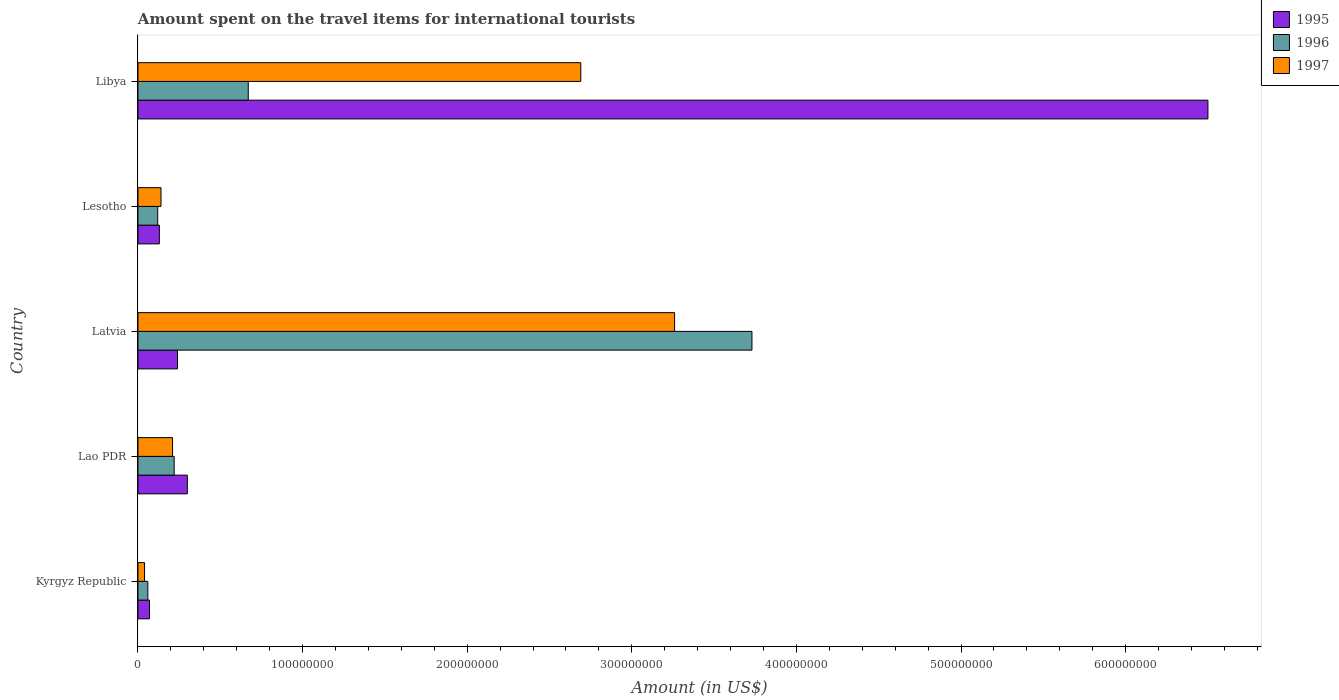How many bars are there on the 1st tick from the top?
Ensure brevity in your answer.  3. What is the label of the 2nd group of bars from the top?
Keep it short and to the point. Lesotho. What is the amount spent on the travel items for international tourists in 1995 in Lesotho?
Ensure brevity in your answer.  1.30e+07. Across all countries, what is the maximum amount spent on the travel items for international tourists in 1995?
Your answer should be very brief. 6.50e+08. Across all countries, what is the minimum amount spent on the travel items for international tourists in 1995?
Your answer should be compact. 7.00e+06. In which country was the amount spent on the travel items for international tourists in 1997 maximum?
Offer a very short reply. Latvia. In which country was the amount spent on the travel items for international tourists in 1996 minimum?
Provide a short and direct response. Kyrgyz Republic. What is the total amount spent on the travel items for international tourists in 1995 in the graph?
Offer a terse response. 7.24e+08. What is the difference between the amount spent on the travel items for international tourists in 1995 in Latvia and that in Lesotho?
Offer a terse response. 1.10e+07. What is the difference between the amount spent on the travel items for international tourists in 1995 in Lesotho and the amount spent on the travel items for international tourists in 1997 in Libya?
Ensure brevity in your answer.  -2.56e+08. What is the average amount spent on the travel items for international tourists in 1997 per country?
Provide a succinct answer. 1.27e+08. What is the difference between the amount spent on the travel items for international tourists in 1996 and amount spent on the travel items for international tourists in 1995 in Kyrgyz Republic?
Your answer should be compact. -1.00e+06. In how many countries, is the amount spent on the travel items for international tourists in 1995 greater than 420000000 US$?
Offer a terse response. 1. What is the ratio of the amount spent on the travel items for international tourists in 1997 in Lao PDR to that in Libya?
Offer a terse response. 0.08. Is the amount spent on the travel items for international tourists in 1997 in Kyrgyz Republic less than that in Libya?
Make the answer very short. Yes. What is the difference between the highest and the second highest amount spent on the travel items for international tourists in 1995?
Provide a succinct answer. 6.20e+08. What is the difference between the highest and the lowest amount spent on the travel items for international tourists in 1995?
Make the answer very short. 6.43e+08. Is the sum of the amount spent on the travel items for international tourists in 1995 in Lao PDR and Lesotho greater than the maximum amount spent on the travel items for international tourists in 1997 across all countries?
Your response must be concise. No. What does the 3rd bar from the bottom in Latvia represents?
Your answer should be compact. 1997. How many bars are there?
Your response must be concise. 15. How many countries are there in the graph?
Make the answer very short. 5. Are the values on the major ticks of X-axis written in scientific E-notation?
Your response must be concise. No. Does the graph contain any zero values?
Make the answer very short. No. How many legend labels are there?
Provide a short and direct response. 3. What is the title of the graph?
Offer a very short reply. Amount spent on the travel items for international tourists. Does "1962" appear as one of the legend labels in the graph?
Keep it short and to the point. No. What is the label or title of the Y-axis?
Your answer should be compact. Country. What is the Amount (in US$) in 1995 in Kyrgyz Republic?
Provide a succinct answer. 7.00e+06. What is the Amount (in US$) in 1997 in Kyrgyz Republic?
Your answer should be very brief. 4.00e+06. What is the Amount (in US$) of 1995 in Lao PDR?
Your answer should be compact. 3.00e+07. What is the Amount (in US$) in 1996 in Lao PDR?
Your answer should be compact. 2.20e+07. What is the Amount (in US$) of 1997 in Lao PDR?
Give a very brief answer. 2.10e+07. What is the Amount (in US$) of 1995 in Latvia?
Offer a very short reply. 2.40e+07. What is the Amount (in US$) of 1996 in Latvia?
Your response must be concise. 3.73e+08. What is the Amount (in US$) of 1997 in Latvia?
Offer a terse response. 3.26e+08. What is the Amount (in US$) in 1995 in Lesotho?
Make the answer very short. 1.30e+07. What is the Amount (in US$) of 1996 in Lesotho?
Offer a very short reply. 1.20e+07. What is the Amount (in US$) of 1997 in Lesotho?
Offer a terse response. 1.40e+07. What is the Amount (in US$) in 1995 in Libya?
Provide a succinct answer. 6.50e+08. What is the Amount (in US$) of 1996 in Libya?
Offer a very short reply. 6.70e+07. What is the Amount (in US$) in 1997 in Libya?
Make the answer very short. 2.69e+08. Across all countries, what is the maximum Amount (in US$) in 1995?
Make the answer very short. 6.50e+08. Across all countries, what is the maximum Amount (in US$) of 1996?
Your response must be concise. 3.73e+08. Across all countries, what is the maximum Amount (in US$) in 1997?
Offer a very short reply. 3.26e+08. Across all countries, what is the minimum Amount (in US$) of 1995?
Ensure brevity in your answer.  7.00e+06. What is the total Amount (in US$) in 1995 in the graph?
Your answer should be very brief. 7.24e+08. What is the total Amount (in US$) of 1996 in the graph?
Provide a succinct answer. 4.80e+08. What is the total Amount (in US$) in 1997 in the graph?
Ensure brevity in your answer.  6.34e+08. What is the difference between the Amount (in US$) of 1995 in Kyrgyz Republic and that in Lao PDR?
Keep it short and to the point. -2.30e+07. What is the difference between the Amount (in US$) of 1996 in Kyrgyz Republic and that in Lao PDR?
Make the answer very short. -1.60e+07. What is the difference between the Amount (in US$) in 1997 in Kyrgyz Republic and that in Lao PDR?
Your answer should be very brief. -1.70e+07. What is the difference between the Amount (in US$) of 1995 in Kyrgyz Republic and that in Latvia?
Provide a succinct answer. -1.70e+07. What is the difference between the Amount (in US$) in 1996 in Kyrgyz Republic and that in Latvia?
Give a very brief answer. -3.67e+08. What is the difference between the Amount (in US$) of 1997 in Kyrgyz Republic and that in Latvia?
Your response must be concise. -3.22e+08. What is the difference between the Amount (in US$) in 1995 in Kyrgyz Republic and that in Lesotho?
Offer a very short reply. -6.00e+06. What is the difference between the Amount (in US$) in 1996 in Kyrgyz Republic and that in Lesotho?
Your answer should be compact. -6.00e+06. What is the difference between the Amount (in US$) of 1997 in Kyrgyz Republic and that in Lesotho?
Keep it short and to the point. -1.00e+07. What is the difference between the Amount (in US$) in 1995 in Kyrgyz Republic and that in Libya?
Provide a short and direct response. -6.43e+08. What is the difference between the Amount (in US$) of 1996 in Kyrgyz Republic and that in Libya?
Your answer should be compact. -6.10e+07. What is the difference between the Amount (in US$) in 1997 in Kyrgyz Republic and that in Libya?
Make the answer very short. -2.65e+08. What is the difference between the Amount (in US$) in 1995 in Lao PDR and that in Latvia?
Keep it short and to the point. 6.00e+06. What is the difference between the Amount (in US$) in 1996 in Lao PDR and that in Latvia?
Provide a succinct answer. -3.51e+08. What is the difference between the Amount (in US$) of 1997 in Lao PDR and that in Latvia?
Provide a succinct answer. -3.05e+08. What is the difference between the Amount (in US$) of 1995 in Lao PDR and that in Lesotho?
Your answer should be very brief. 1.70e+07. What is the difference between the Amount (in US$) of 1997 in Lao PDR and that in Lesotho?
Offer a very short reply. 7.00e+06. What is the difference between the Amount (in US$) of 1995 in Lao PDR and that in Libya?
Keep it short and to the point. -6.20e+08. What is the difference between the Amount (in US$) of 1996 in Lao PDR and that in Libya?
Your answer should be very brief. -4.50e+07. What is the difference between the Amount (in US$) in 1997 in Lao PDR and that in Libya?
Your answer should be compact. -2.48e+08. What is the difference between the Amount (in US$) in 1995 in Latvia and that in Lesotho?
Make the answer very short. 1.10e+07. What is the difference between the Amount (in US$) of 1996 in Latvia and that in Lesotho?
Provide a succinct answer. 3.61e+08. What is the difference between the Amount (in US$) in 1997 in Latvia and that in Lesotho?
Provide a short and direct response. 3.12e+08. What is the difference between the Amount (in US$) of 1995 in Latvia and that in Libya?
Keep it short and to the point. -6.26e+08. What is the difference between the Amount (in US$) of 1996 in Latvia and that in Libya?
Your answer should be compact. 3.06e+08. What is the difference between the Amount (in US$) in 1997 in Latvia and that in Libya?
Provide a short and direct response. 5.70e+07. What is the difference between the Amount (in US$) in 1995 in Lesotho and that in Libya?
Your answer should be compact. -6.37e+08. What is the difference between the Amount (in US$) of 1996 in Lesotho and that in Libya?
Offer a very short reply. -5.50e+07. What is the difference between the Amount (in US$) in 1997 in Lesotho and that in Libya?
Ensure brevity in your answer.  -2.55e+08. What is the difference between the Amount (in US$) of 1995 in Kyrgyz Republic and the Amount (in US$) of 1996 in Lao PDR?
Your answer should be very brief. -1.50e+07. What is the difference between the Amount (in US$) of 1995 in Kyrgyz Republic and the Amount (in US$) of 1997 in Lao PDR?
Make the answer very short. -1.40e+07. What is the difference between the Amount (in US$) of 1996 in Kyrgyz Republic and the Amount (in US$) of 1997 in Lao PDR?
Your response must be concise. -1.50e+07. What is the difference between the Amount (in US$) of 1995 in Kyrgyz Republic and the Amount (in US$) of 1996 in Latvia?
Keep it short and to the point. -3.66e+08. What is the difference between the Amount (in US$) of 1995 in Kyrgyz Republic and the Amount (in US$) of 1997 in Latvia?
Make the answer very short. -3.19e+08. What is the difference between the Amount (in US$) of 1996 in Kyrgyz Republic and the Amount (in US$) of 1997 in Latvia?
Keep it short and to the point. -3.20e+08. What is the difference between the Amount (in US$) of 1995 in Kyrgyz Republic and the Amount (in US$) of 1996 in Lesotho?
Your answer should be very brief. -5.00e+06. What is the difference between the Amount (in US$) in 1995 in Kyrgyz Republic and the Amount (in US$) in 1997 in Lesotho?
Your response must be concise. -7.00e+06. What is the difference between the Amount (in US$) of 1996 in Kyrgyz Republic and the Amount (in US$) of 1997 in Lesotho?
Provide a short and direct response. -8.00e+06. What is the difference between the Amount (in US$) in 1995 in Kyrgyz Republic and the Amount (in US$) in 1996 in Libya?
Give a very brief answer. -6.00e+07. What is the difference between the Amount (in US$) of 1995 in Kyrgyz Republic and the Amount (in US$) of 1997 in Libya?
Your response must be concise. -2.62e+08. What is the difference between the Amount (in US$) in 1996 in Kyrgyz Republic and the Amount (in US$) in 1997 in Libya?
Your response must be concise. -2.63e+08. What is the difference between the Amount (in US$) of 1995 in Lao PDR and the Amount (in US$) of 1996 in Latvia?
Offer a terse response. -3.43e+08. What is the difference between the Amount (in US$) in 1995 in Lao PDR and the Amount (in US$) in 1997 in Latvia?
Offer a terse response. -2.96e+08. What is the difference between the Amount (in US$) of 1996 in Lao PDR and the Amount (in US$) of 1997 in Latvia?
Provide a succinct answer. -3.04e+08. What is the difference between the Amount (in US$) of 1995 in Lao PDR and the Amount (in US$) of 1996 in Lesotho?
Offer a terse response. 1.80e+07. What is the difference between the Amount (in US$) of 1995 in Lao PDR and the Amount (in US$) of 1997 in Lesotho?
Offer a very short reply. 1.60e+07. What is the difference between the Amount (in US$) in 1996 in Lao PDR and the Amount (in US$) in 1997 in Lesotho?
Ensure brevity in your answer.  8.00e+06. What is the difference between the Amount (in US$) in 1995 in Lao PDR and the Amount (in US$) in 1996 in Libya?
Your response must be concise. -3.70e+07. What is the difference between the Amount (in US$) of 1995 in Lao PDR and the Amount (in US$) of 1997 in Libya?
Offer a very short reply. -2.39e+08. What is the difference between the Amount (in US$) in 1996 in Lao PDR and the Amount (in US$) in 1997 in Libya?
Ensure brevity in your answer.  -2.47e+08. What is the difference between the Amount (in US$) in 1996 in Latvia and the Amount (in US$) in 1997 in Lesotho?
Offer a very short reply. 3.59e+08. What is the difference between the Amount (in US$) of 1995 in Latvia and the Amount (in US$) of 1996 in Libya?
Provide a short and direct response. -4.30e+07. What is the difference between the Amount (in US$) of 1995 in Latvia and the Amount (in US$) of 1997 in Libya?
Provide a short and direct response. -2.45e+08. What is the difference between the Amount (in US$) of 1996 in Latvia and the Amount (in US$) of 1997 in Libya?
Ensure brevity in your answer.  1.04e+08. What is the difference between the Amount (in US$) in 1995 in Lesotho and the Amount (in US$) in 1996 in Libya?
Your answer should be compact. -5.40e+07. What is the difference between the Amount (in US$) of 1995 in Lesotho and the Amount (in US$) of 1997 in Libya?
Make the answer very short. -2.56e+08. What is the difference between the Amount (in US$) of 1996 in Lesotho and the Amount (in US$) of 1997 in Libya?
Your answer should be compact. -2.57e+08. What is the average Amount (in US$) of 1995 per country?
Provide a short and direct response. 1.45e+08. What is the average Amount (in US$) in 1996 per country?
Ensure brevity in your answer.  9.60e+07. What is the average Amount (in US$) in 1997 per country?
Make the answer very short. 1.27e+08. What is the difference between the Amount (in US$) in 1995 and Amount (in US$) in 1996 in Kyrgyz Republic?
Offer a terse response. 1.00e+06. What is the difference between the Amount (in US$) in 1995 and Amount (in US$) in 1997 in Kyrgyz Republic?
Provide a succinct answer. 3.00e+06. What is the difference between the Amount (in US$) in 1995 and Amount (in US$) in 1996 in Lao PDR?
Give a very brief answer. 8.00e+06. What is the difference between the Amount (in US$) of 1995 and Amount (in US$) of 1997 in Lao PDR?
Offer a terse response. 9.00e+06. What is the difference between the Amount (in US$) in 1995 and Amount (in US$) in 1996 in Latvia?
Give a very brief answer. -3.49e+08. What is the difference between the Amount (in US$) in 1995 and Amount (in US$) in 1997 in Latvia?
Keep it short and to the point. -3.02e+08. What is the difference between the Amount (in US$) of 1996 and Amount (in US$) of 1997 in Latvia?
Provide a succinct answer. 4.70e+07. What is the difference between the Amount (in US$) of 1995 and Amount (in US$) of 1996 in Lesotho?
Provide a succinct answer. 1.00e+06. What is the difference between the Amount (in US$) of 1995 and Amount (in US$) of 1996 in Libya?
Ensure brevity in your answer.  5.83e+08. What is the difference between the Amount (in US$) in 1995 and Amount (in US$) in 1997 in Libya?
Make the answer very short. 3.81e+08. What is the difference between the Amount (in US$) of 1996 and Amount (in US$) of 1997 in Libya?
Your answer should be compact. -2.02e+08. What is the ratio of the Amount (in US$) of 1995 in Kyrgyz Republic to that in Lao PDR?
Your answer should be very brief. 0.23. What is the ratio of the Amount (in US$) of 1996 in Kyrgyz Republic to that in Lao PDR?
Offer a terse response. 0.27. What is the ratio of the Amount (in US$) in 1997 in Kyrgyz Republic to that in Lao PDR?
Offer a terse response. 0.19. What is the ratio of the Amount (in US$) in 1995 in Kyrgyz Republic to that in Latvia?
Give a very brief answer. 0.29. What is the ratio of the Amount (in US$) in 1996 in Kyrgyz Republic to that in Latvia?
Provide a succinct answer. 0.02. What is the ratio of the Amount (in US$) in 1997 in Kyrgyz Republic to that in Latvia?
Offer a very short reply. 0.01. What is the ratio of the Amount (in US$) in 1995 in Kyrgyz Republic to that in Lesotho?
Provide a short and direct response. 0.54. What is the ratio of the Amount (in US$) in 1997 in Kyrgyz Republic to that in Lesotho?
Your response must be concise. 0.29. What is the ratio of the Amount (in US$) of 1995 in Kyrgyz Republic to that in Libya?
Your response must be concise. 0.01. What is the ratio of the Amount (in US$) of 1996 in Kyrgyz Republic to that in Libya?
Make the answer very short. 0.09. What is the ratio of the Amount (in US$) in 1997 in Kyrgyz Republic to that in Libya?
Keep it short and to the point. 0.01. What is the ratio of the Amount (in US$) in 1995 in Lao PDR to that in Latvia?
Ensure brevity in your answer.  1.25. What is the ratio of the Amount (in US$) in 1996 in Lao PDR to that in Latvia?
Your response must be concise. 0.06. What is the ratio of the Amount (in US$) of 1997 in Lao PDR to that in Latvia?
Make the answer very short. 0.06. What is the ratio of the Amount (in US$) in 1995 in Lao PDR to that in Lesotho?
Your answer should be compact. 2.31. What is the ratio of the Amount (in US$) of 1996 in Lao PDR to that in Lesotho?
Give a very brief answer. 1.83. What is the ratio of the Amount (in US$) of 1997 in Lao PDR to that in Lesotho?
Your answer should be compact. 1.5. What is the ratio of the Amount (in US$) of 1995 in Lao PDR to that in Libya?
Provide a short and direct response. 0.05. What is the ratio of the Amount (in US$) of 1996 in Lao PDR to that in Libya?
Offer a terse response. 0.33. What is the ratio of the Amount (in US$) in 1997 in Lao PDR to that in Libya?
Provide a succinct answer. 0.08. What is the ratio of the Amount (in US$) in 1995 in Latvia to that in Lesotho?
Offer a very short reply. 1.85. What is the ratio of the Amount (in US$) of 1996 in Latvia to that in Lesotho?
Give a very brief answer. 31.08. What is the ratio of the Amount (in US$) in 1997 in Latvia to that in Lesotho?
Give a very brief answer. 23.29. What is the ratio of the Amount (in US$) of 1995 in Latvia to that in Libya?
Your answer should be compact. 0.04. What is the ratio of the Amount (in US$) in 1996 in Latvia to that in Libya?
Give a very brief answer. 5.57. What is the ratio of the Amount (in US$) of 1997 in Latvia to that in Libya?
Your response must be concise. 1.21. What is the ratio of the Amount (in US$) in 1996 in Lesotho to that in Libya?
Keep it short and to the point. 0.18. What is the ratio of the Amount (in US$) in 1997 in Lesotho to that in Libya?
Make the answer very short. 0.05. What is the difference between the highest and the second highest Amount (in US$) in 1995?
Your answer should be very brief. 6.20e+08. What is the difference between the highest and the second highest Amount (in US$) of 1996?
Your answer should be compact. 3.06e+08. What is the difference between the highest and the second highest Amount (in US$) in 1997?
Provide a short and direct response. 5.70e+07. What is the difference between the highest and the lowest Amount (in US$) of 1995?
Make the answer very short. 6.43e+08. What is the difference between the highest and the lowest Amount (in US$) of 1996?
Make the answer very short. 3.67e+08. What is the difference between the highest and the lowest Amount (in US$) of 1997?
Your answer should be compact. 3.22e+08. 